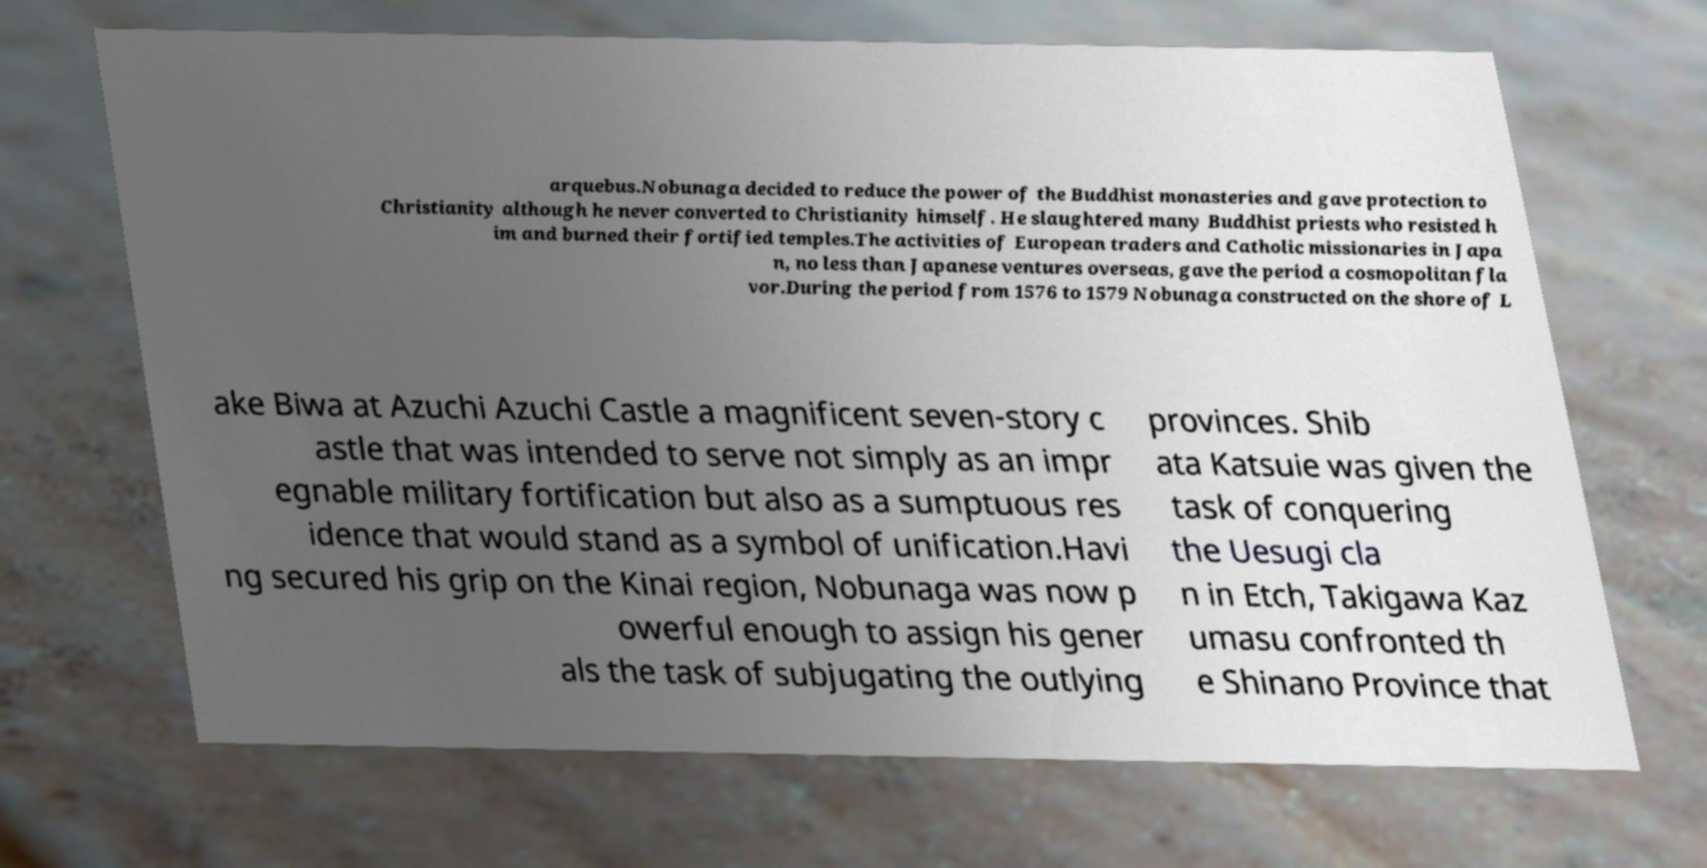Can you read and provide the text displayed in the image?This photo seems to have some interesting text. Can you extract and type it out for me? arquebus.Nobunaga decided to reduce the power of the Buddhist monasteries and gave protection to Christianity although he never converted to Christianity himself. He slaughtered many Buddhist priests who resisted h im and burned their fortified temples.The activities of European traders and Catholic missionaries in Japa n, no less than Japanese ventures overseas, gave the period a cosmopolitan fla vor.During the period from 1576 to 1579 Nobunaga constructed on the shore of L ake Biwa at Azuchi Azuchi Castle a magnificent seven-story c astle that was intended to serve not simply as an impr egnable military fortification but also as a sumptuous res idence that would stand as a symbol of unification.Havi ng secured his grip on the Kinai region, Nobunaga was now p owerful enough to assign his gener als the task of subjugating the outlying provinces. Shib ata Katsuie was given the task of conquering the Uesugi cla n in Etch, Takigawa Kaz umasu confronted th e Shinano Province that 